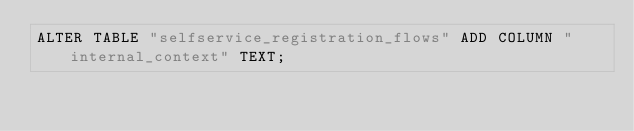<code> <loc_0><loc_0><loc_500><loc_500><_SQL_>ALTER TABLE "selfservice_registration_flows" ADD COLUMN "internal_context" TEXT;</code> 